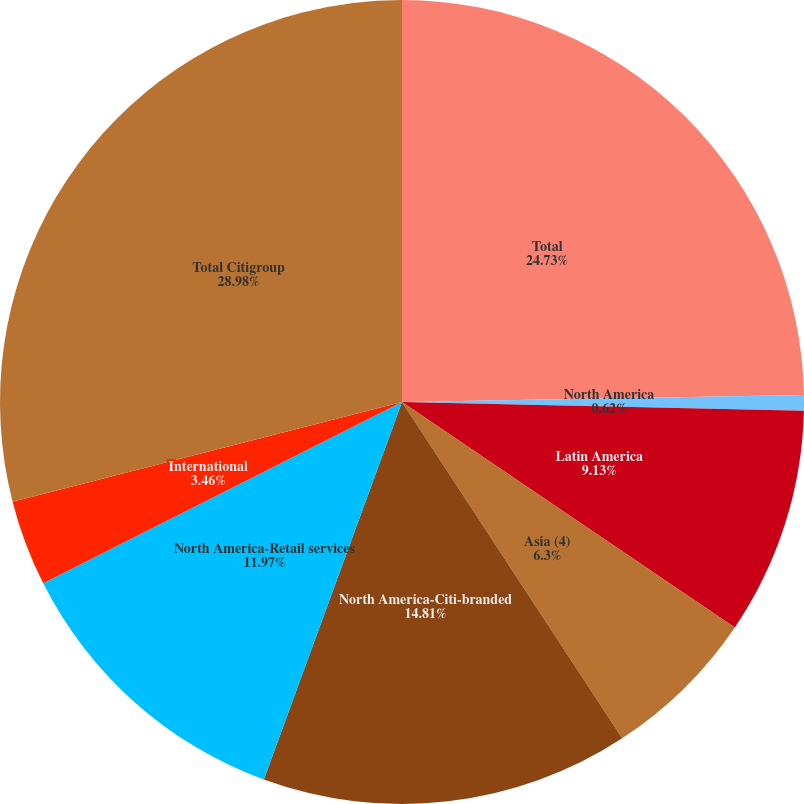<chart> <loc_0><loc_0><loc_500><loc_500><pie_chart><fcel>Total<fcel>North America<fcel>Latin America<fcel>Asia (4)<fcel>North America-Citi-branded<fcel>North America-Retail services<fcel>International<fcel>Total Citigroup<nl><fcel>24.73%<fcel>0.62%<fcel>9.13%<fcel>6.3%<fcel>14.81%<fcel>11.97%<fcel>3.46%<fcel>28.99%<nl></chart> 